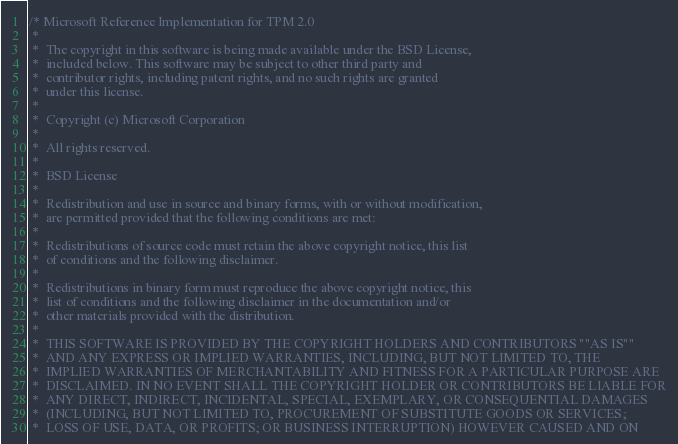<code> <loc_0><loc_0><loc_500><loc_500><_C_>/* Microsoft Reference Implementation for TPM 2.0
 *
 *  The copyright in this software is being made available under the BSD License,
 *  included below. This software may be subject to other third party and
 *  contributor rights, including patent rights, and no such rights are granted
 *  under this license.
 *
 *  Copyright (c) Microsoft Corporation
 *
 *  All rights reserved.
 *
 *  BSD License
 *
 *  Redistribution and use in source and binary forms, with or without modification,
 *  are permitted provided that the following conditions are met:
 *
 *  Redistributions of source code must retain the above copyright notice, this list
 *  of conditions and the following disclaimer.
 *
 *  Redistributions in binary form must reproduce the above copyright notice, this
 *  list of conditions and the following disclaimer in the documentation and/or
 *  other materials provided with the distribution.
 *
 *  THIS SOFTWARE IS PROVIDED BY THE COPYRIGHT HOLDERS AND CONTRIBUTORS ""AS IS""
 *  AND ANY EXPRESS OR IMPLIED WARRANTIES, INCLUDING, BUT NOT LIMITED TO, THE
 *  IMPLIED WARRANTIES OF MERCHANTABILITY AND FITNESS FOR A PARTICULAR PURPOSE ARE
 *  DISCLAIMED. IN NO EVENT SHALL THE COPYRIGHT HOLDER OR CONTRIBUTORS BE LIABLE FOR
 *  ANY DIRECT, INDIRECT, INCIDENTAL, SPECIAL, EXEMPLARY, OR CONSEQUENTIAL DAMAGES
 *  (INCLUDING, BUT NOT LIMITED TO, PROCUREMENT OF SUBSTITUTE GOODS OR SERVICES;
 *  LOSS OF USE, DATA, OR PROFITS; OR BUSINESS INTERRUPTION) HOWEVER CAUSED AND ON</code> 